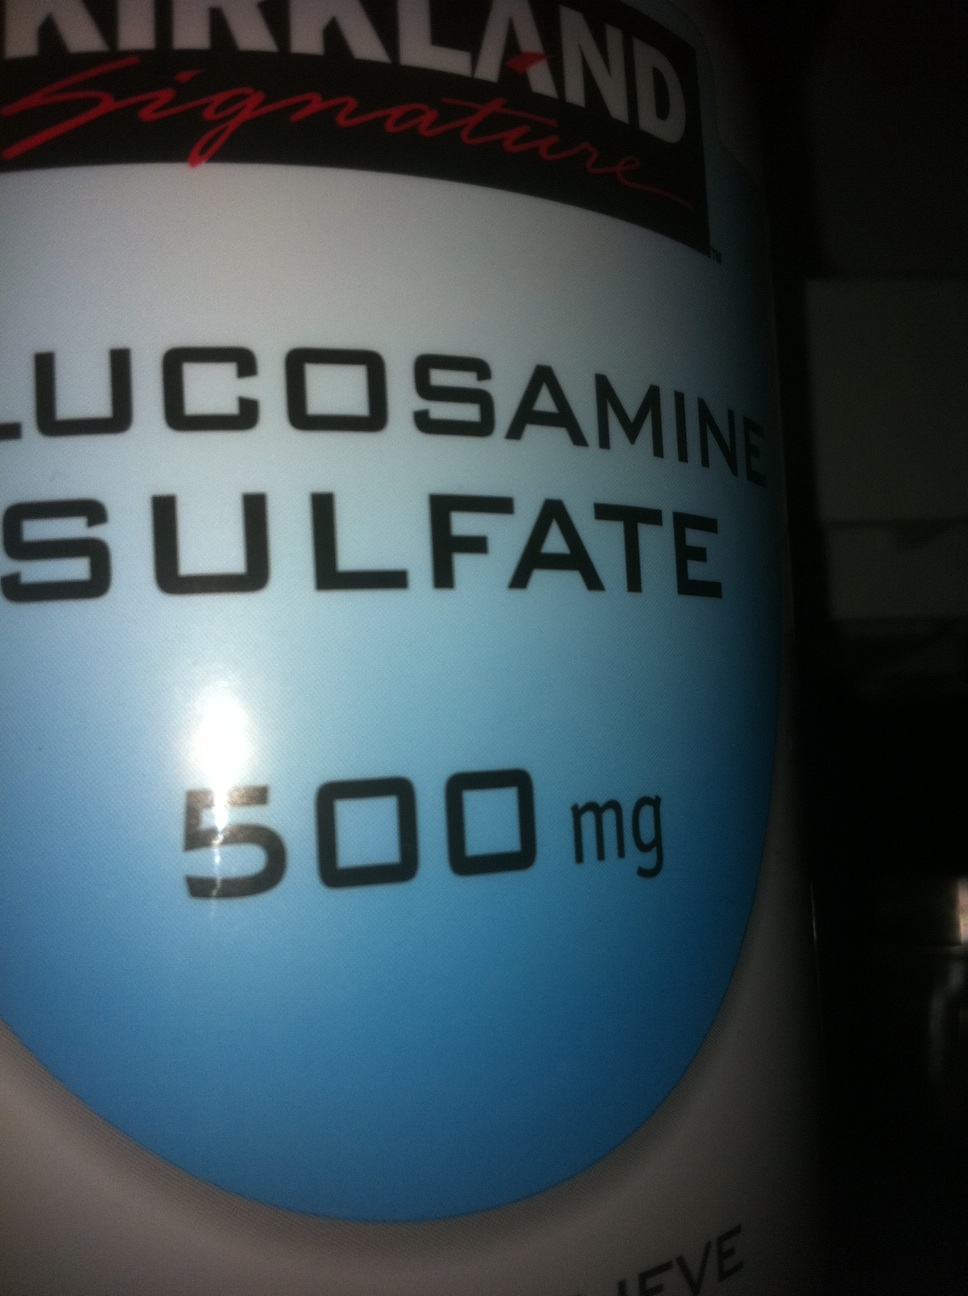Imagine if this bottle could talk, what story do you think it would tell about its journey from the manufacturer to someone's home? If this bottle could talk, it might begin its tale at a bustling factory where countless containers are filled with glucosharegpt4v/samine sulfate powder, carefully measured to ensure consistency and quality. It would reminisce about the systematic checks and rigorous testing it underwent before being sealed and packaged. The journey then takes a turn as it joins its fellow bottles in a shipping box, traveling through various distribution centers, experiencing the gentle hum of delivery vehicles. Finally, it reaches its destination – a cozy home where it is taken out of the box, making a new place in a bathroom or kitchen cabinet. Here, it finds its purpose, aiding its owner in the quest for joint health, becoming a daily part of someone’s routine, striving to offer comfort and relief through its humble 500 mg dose. 